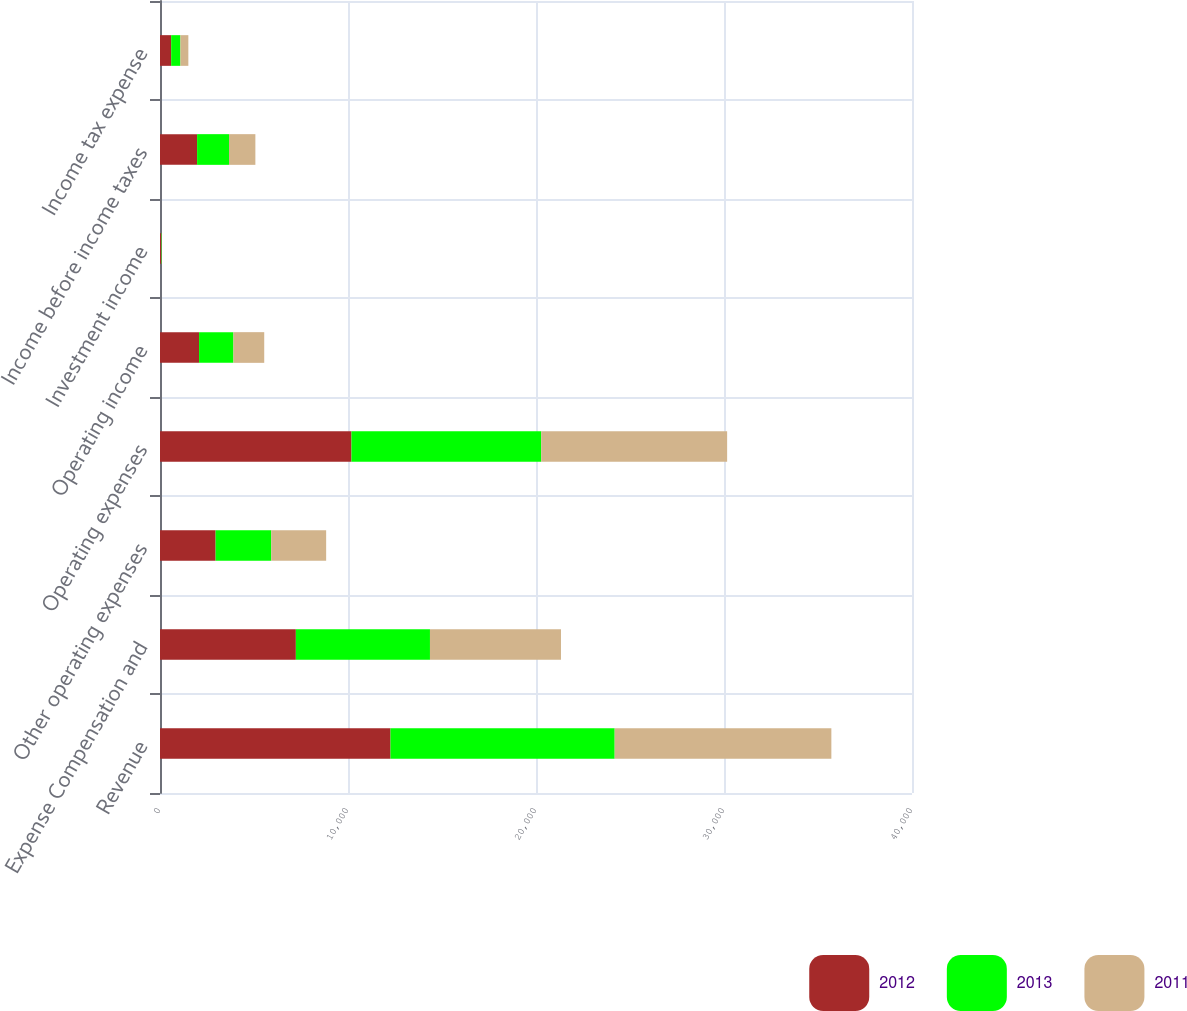<chart> <loc_0><loc_0><loc_500><loc_500><stacked_bar_chart><ecel><fcel>Revenue<fcel>Expense Compensation and<fcel>Other operating expenses<fcel>Operating expenses<fcel>Operating income<fcel>Investment income<fcel>Income before income taxes<fcel>Income tax expense<nl><fcel>2012<fcel>12261<fcel>7226<fcel>2958<fcel>10184<fcel>2077<fcel>69<fcel>1973<fcel>594<nl><fcel>2013<fcel>11924<fcel>7134<fcel>2961<fcel>10095<fcel>1829<fcel>24<fcel>1696<fcel>492<nl><fcel>2011<fcel>11526<fcel>6969<fcel>2919<fcel>9888<fcel>1638<fcel>9<fcel>1404<fcel>422<nl></chart> 